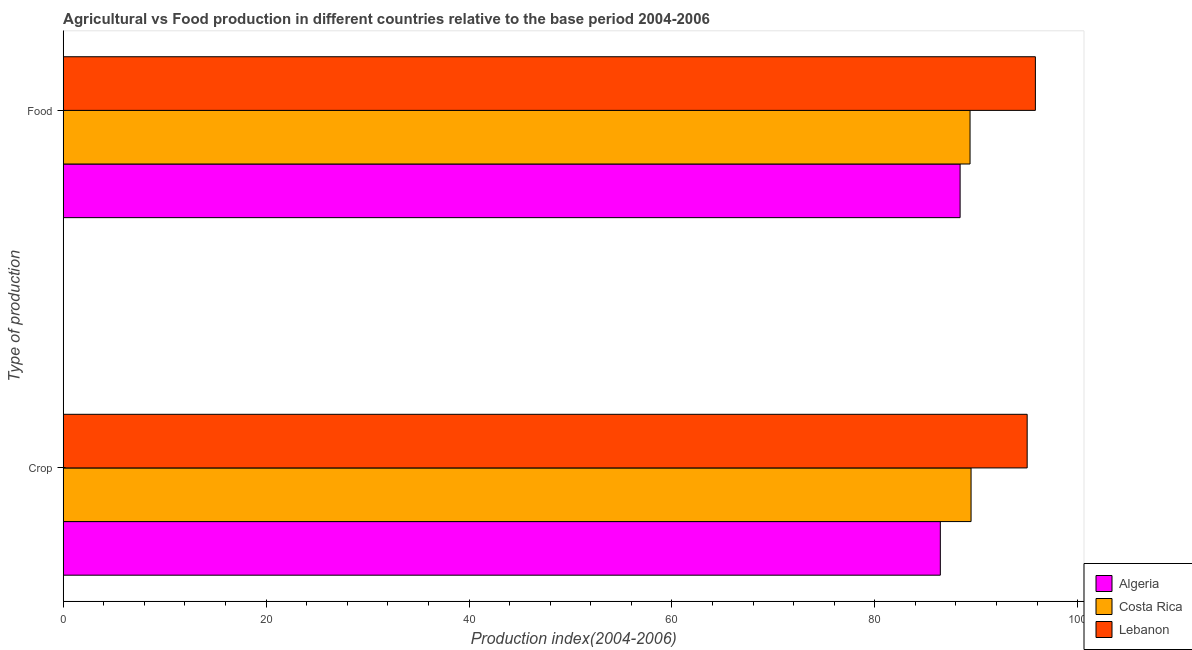How many different coloured bars are there?
Make the answer very short. 3. How many groups of bars are there?
Keep it short and to the point. 2. Are the number of bars on each tick of the Y-axis equal?
Offer a terse response. Yes. What is the label of the 1st group of bars from the top?
Offer a terse response. Food. What is the food production index in Lebanon?
Make the answer very short. 95.83. Across all countries, what is the maximum crop production index?
Give a very brief answer. 95.02. Across all countries, what is the minimum food production index?
Offer a very short reply. 88.41. In which country was the crop production index maximum?
Your answer should be very brief. Lebanon. In which country was the food production index minimum?
Your response must be concise. Algeria. What is the total crop production index in the graph?
Your response must be concise. 270.97. What is the difference between the crop production index in Lebanon and that in Algeria?
Your answer should be very brief. 8.56. What is the difference between the food production index in Algeria and the crop production index in Lebanon?
Ensure brevity in your answer.  -6.61. What is the average crop production index per country?
Keep it short and to the point. 90.32. What is the difference between the crop production index and food production index in Costa Rica?
Give a very brief answer. 0.1. In how many countries, is the crop production index greater than 76 ?
Your answer should be compact. 3. What is the ratio of the crop production index in Algeria to that in Lebanon?
Make the answer very short. 0.91. What does the 1st bar from the top in Crop represents?
Keep it short and to the point. Lebanon. What does the 1st bar from the bottom in Crop represents?
Give a very brief answer. Algeria. How many countries are there in the graph?
Give a very brief answer. 3. What is the difference between two consecutive major ticks on the X-axis?
Offer a terse response. 20. Does the graph contain grids?
Your response must be concise. No. How many legend labels are there?
Offer a very short reply. 3. What is the title of the graph?
Your answer should be very brief. Agricultural vs Food production in different countries relative to the base period 2004-2006. What is the label or title of the X-axis?
Your answer should be very brief. Production index(2004-2006). What is the label or title of the Y-axis?
Keep it short and to the point. Type of production. What is the Production index(2004-2006) of Algeria in Crop?
Make the answer very short. 86.46. What is the Production index(2004-2006) of Costa Rica in Crop?
Ensure brevity in your answer.  89.49. What is the Production index(2004-2006) in Lebanon in Crop?
Ensure brevity in your answer.  95.02. What is the Production index(2004-2006) of Algeria in Food?
Ensure brevity in your answer.  88.41. What is the Production index(2004-2006) in Costa Rica in Food?
Your answer should be very brief. 89.39. What is the Production index(2004-2006) of Lebanon in Food?
Your response must be concise. 95.83. Across all Type of production, what is the maximum Production index(2004-2006) in Algeria?
Provide a short and direct response. 88.41. Across all Type of production, what is the maximum Production index(2004-2006) in Costa Rica?
Make the answer very short. 89.49. Across all Type of production, what is the maximum Production index(2004-2006) in Lebanon?
Keep it short and to the point. 95.83. Across all Type of production, what is the minimum Production index(2004-2006) in Algeria?
Ensure brevity in your answer.  86.46. Across all Type of production, what is the minimum Production index(2004-2006) in Costa Rica?
Make the answer very short. 89.39. Across all Type of production, what is the minimum Production index(2004-2006) of Lebanon?
Give a very brief answer. 95.02. What is the total Production index(2004-2006) in Algeria in the graph?
Offer a very short reply. 174.87. What is the total Production index(2004-2006) of Costa Rica in the graph?
Make the answer very short. 178.88. What is the total Production index(2004-2006) of Lebanon in the graph?
Offer a very short reply. 190.85. What is the difference between the Production index(2004-2006) of Algeria in Crop and that in Food?
Your answer should be very brief. -1.95. What is the difference between the Production index(2004-2006) in Lebanon in Crop and that in Food?
Offer a very short reply. -0.81. What is the difference between the Production index(2004-2006) in Algeria in Crop and the Production index(2004-2006) in Costa Rica in Food?
Offer a terse response. -2.93. What is the difference between the Production index(2004-2006) of Algeria in Crop and the Production index(2004-2006) of Lebanon in Food?
Your answer should be very brief. -9.37. What is the difference between the Production index(2004-2006) of Costa Rica in Crop and the Production index(2004-2006) of Lebanon in Food?
Provide a succinct answer. -6.34. What is the average Production index(2004-2006) in Algeria per Type of production?
Offer a terse response. 87.44. What is the average Production index(2004-2006) of Costa Rica per Type of production?
Your answer should be compact. 89.44. What is the average Production index(2004-2006) of Lebanon per Type of production?
Provide a succinct answer. 95.42. What is the difference between the Production index(2004-2006) in Algeria and Production index(2004-2006) in Costa Rica in Crop?
Offer a very short reply. -3.03. What is the difference between the Production index(2004-2006) in Algeria and Production index(2004-2006) in Lebanon in Crop?
Ensure brevity in your answer.  -8.56. What is the difference between the Production index(2004-2006) in Costa Rica and Production index(2004-2006) in Lebanon in Crop?
Keep it short and to the point. -5.53. What is the difference between the Production index(2004-2006) in Algeria and Production index(2004-2006) in Costa Rica in Food?
Give a very brief answer. -0.98. What is the difference between the Production index(2004-2006) of Algeria and Production index(2004-2006) of Lebanon in Food?
Your answer should be very brief. -7.42. What is the difference between the Production index(2004-2006) in Costa Rica and Production index(2004-2006) in Lebanon in Food?
Your answer should be very brief. -6.44. What is the ratio of the Production index(2004-2006) of Algeria in Crop to that in Food?
Offer a terse response. 0.98. What is the ratio of the Production index(2004-2006) of Lebanon in Crop to that in Food?
Your answer should be compact. 0.99. What is the difference between the highest and the second highest Production index(2004-2006) in Algeria?
Make the answer very short. 1.95. What is the difference between the highest and the second highest Production index(2004-2006) in Lebanon?
Provide a short and direct response. 0.81. What is the difference between the highest and the lowest Production index(2004-2006) of Algeria?
Your answer should be compact. 1.95. What is the difference between the highest and the lowest Production index(2004-2006) of Costa Rica?
Offer a very short reply. 0.1. What is the difference between the highest and the lowest Production index(2004-2006) in Lebanon?
Offer a terse response. 0.81. 